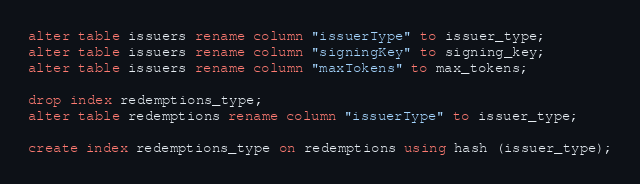<code> <loc_0><loc_0><loc_500><loc_500><_SQL_>alter table issuers rename column "issuerType" to issuer_type;
alter table issuers rename column "signingKey" to signing_key;
alter table issuers rename column "maxTokens" to max_tokens;

drop index redemptions_type;
alter table redemptions rename column "issuerType" to issuer_type;

create index redemptions_type on redemptions using hash (issuer_type);
</code> 